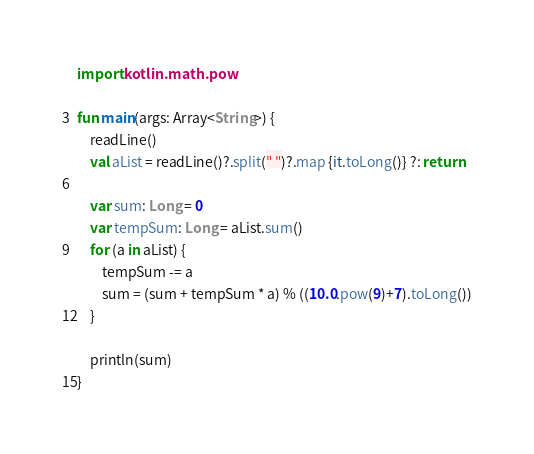Convert code to text. <code><loc_0><loc_0><loc_500><loc_500><_Kotlin_>import kotlin.math.pow

fun main(args: Array<String>) {
	readLine()
	val aList = readLine()?.split(" ")?.map {it.toLong()} ?: return
	
	var sum: Long = 0
	var tempSum: Long = aList.sum()
	for (a in aList) {
		tempSum -= a
		sum = (sum + tempSum * a) % ((10.0.pow(9)+7).toLong())
	}
	
	println(sum)
}</code> 